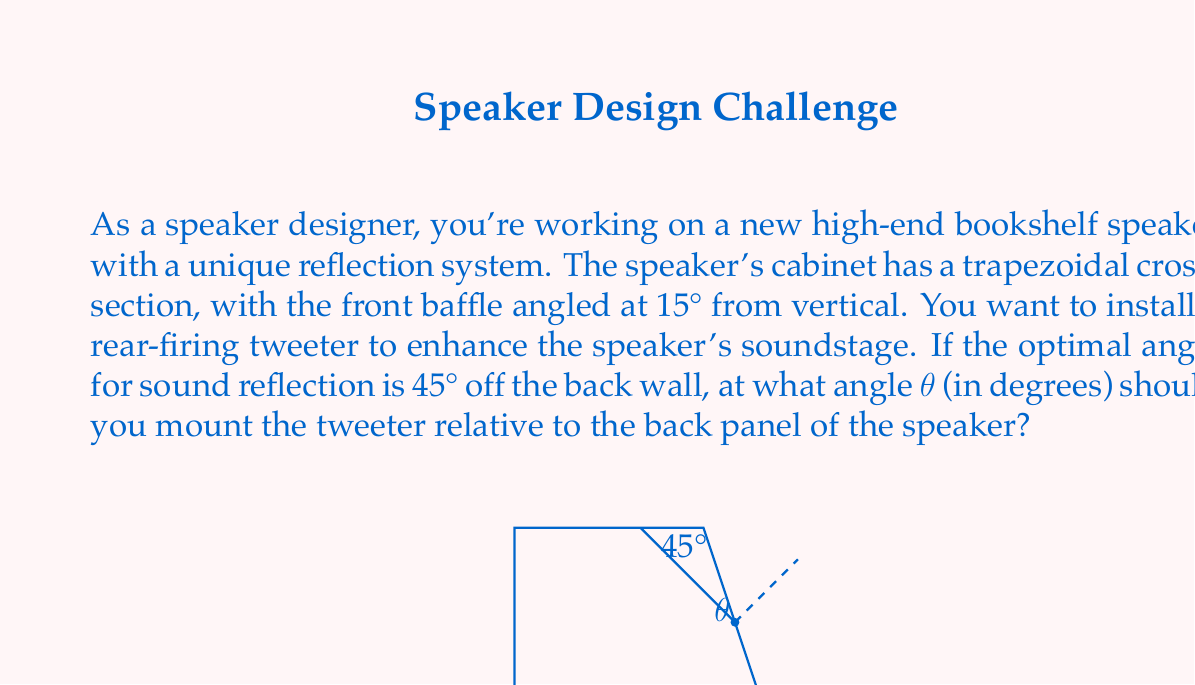Help me with this question. Let's approach this step-by-step:

1) First, we need to understand the geometry of the problem. The back panel of the speaker is at a 15° angle from vertical, and we want the sound to reflect at a 45° angle from the wall.

2) We can use the principle that the angle of incidence equals the angle of reflection. This means that the angle between the tweeter's axis and the back panel should be half of the desired reflection angle.

3) The desired reflection angle is 45°, so the angle between the tweeter's axis and the back panel should be:

   $$\frac{45°}{2} = 22.5°$$

4) However, we need to account for the 15° tilt of the back panel. The tweeter angle θ we're looking for is relative to the back panel, not to the vertical.

5) To find θ, we need to subtract the back panel's tilt from the calculated angle:

   $$θ = 22.5° - 15° = 7.5°$$

This means the tweeter should be mounted at a 7.5° angle relative to the back panel of the speaker.
Answer: The tweeter should be mounted at an angle of θ = 7.5° relative to the back panel of the speaker. 